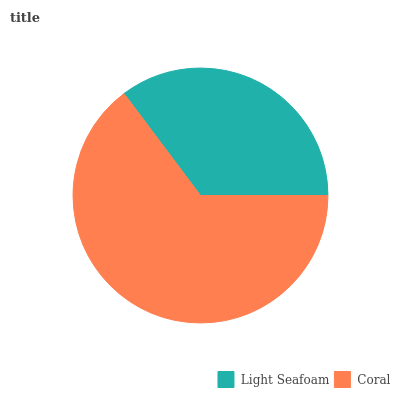Is Light Seafoam the minimum?
Answer yes or no. Yes. Is Coral the maximum?
Answer yes or no. Yes. Is Coral the minimum?
Answer yes or no. No. Is Coral greater than Light Seafoam?
Answer yes or no. Yes. Is Light Seafoam less than Coral?
Answer yes or no. Yes. Is Light Seafoam greater than Coral?
Answer yes or no. No. Is Coral less than Light Seafoam?
Answer yes or no. No. Is Coral the high median?
Answer yes or no. Yes. Is Light Seafoam the low median?
Answer yes or no. Yes. Is Light Seafoam the high median?
Answer yes or no. No. Is Coral the low median?
Answer yes or no. No. 